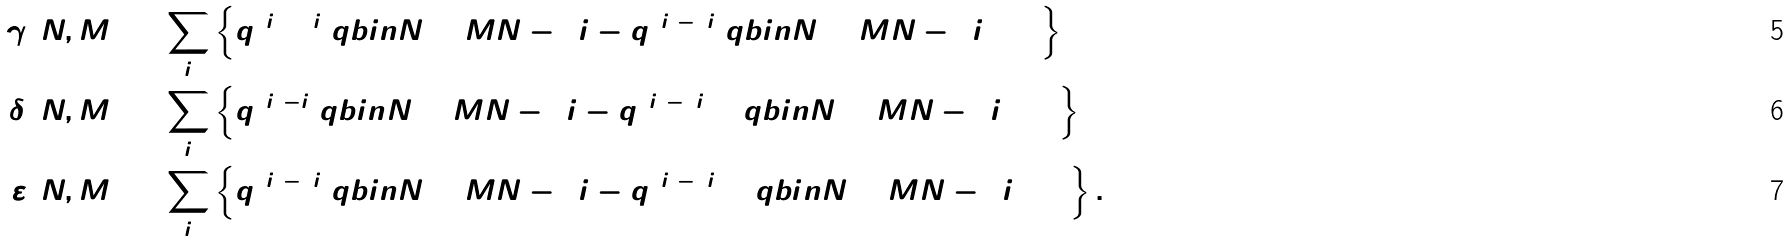Convert formula to latex. <formula><loc_0><loc_0><loc_500><loc_500>\gamma ( N , M ) & = \sum _ { i } \left \{ q ^ { 6 i ^ { 2 } + 2 i } \ q b i n { N + M } { N - 3 i } - q ^ { 6 i ^ { 2 } - 2 i } \ q b i n { N + M } { N - 3 i + 1 } \right \} \\ \delta ( N , M ) & = \sum _ { i } \left \{ q ^ { 6 i ^ { 2 } - i } \ q b i n { N + M } { N - 3 i } - q ^ { 6 i ^ { 2 } - 5 i + 1 } \ q b i n { N + M } { N - 3 i + 1 } \right \} \\ \varepsilon ( N , M ) & = \sum _ { i } \left \{ q ^ { 6 i ^ { 2 } - 4 i } \ q b i n { N + M } { N - 3 i } - q ^ { 6 i ^ { 2 } - 8 i + 2 } \ q b i n { N + M } { N - 3 i + 1 } \right \} .</formula> 